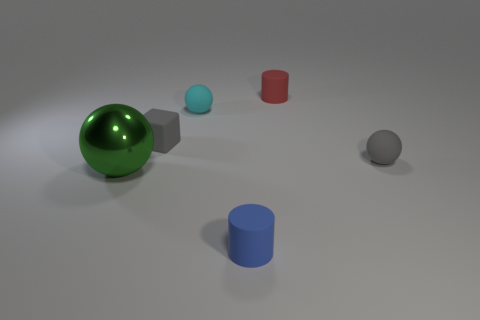What number of green metal cylinders are there?
Provide a short and direct response. 0. Do the green thing and the gray object right of the block have the same material?
Provide a succinct answer. No. What is the material of the small sphere that is the same color as the rubber cube?
Your answer should be compact. Rubber. How many small objects have the same color as the small block?
Keep it short and to the point. 1. The cyan object has what size?
Make the answer very short. Small. There is a small cyan object; is it the same shape as the small matte thing that is in front of the green thing?
Give a very brief answer. No. What color is the other small sphere that is made of the same material as the cyan ball?
Your answer should be compact. Gray. How big is the object on the left side of the rubber cube?
Offer a very short reply. Large. Is the number of red matte cylinders that are behind the blue thing less than the number of tiny things?
Your answer should be very brief. Yes. Are there fewer small blue things than green matte things?
Provide a short and direct response. No. 